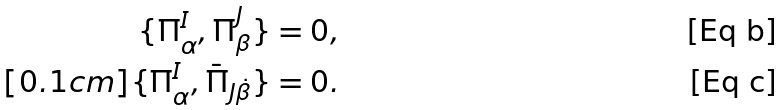Convert formula to latex. <formula><loc_0><loc_0><loc_500><loc_500>\{ \Pi ^ { I } _ { \alpha } , \Pi ^ { J } _ { \beta } \} & = 0 , \\ [ 0 . 1 c m ] \{ \Pi ^ { I } _ { \alpha } , \bar { \Pi } _ { J \dot { \beta } } \} & = 0 .</formula> 